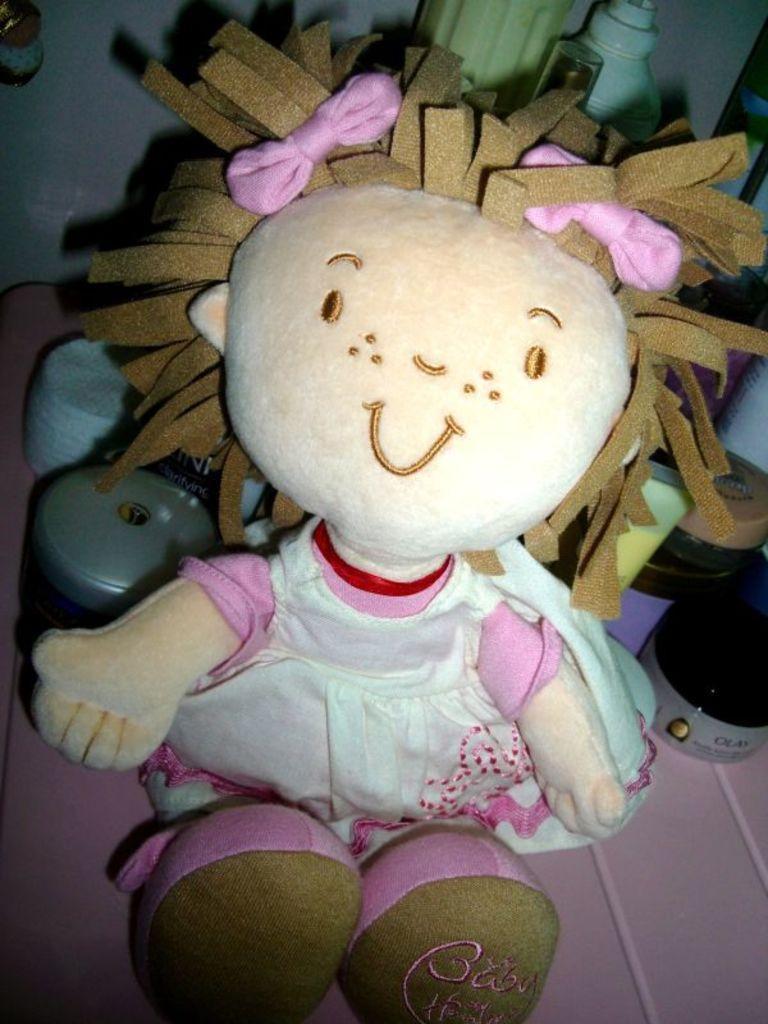Please provide a concise description of this image. In this picture there is a doll in the center of the image and there are bottles in the background area of the image. 